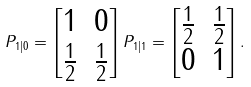<formula> <loc_0><loc_0><loc_500><loc_500>P _ { 1 | 0 } = \begin{bmatrix} 1 & 0 \\ \frac { 1 } { 2 } & \frac { 1 } { 2 } \\ \end{bmatrix} P _ { 1 | 1 } = \begin{bmatrix} \frac { 1 } { 2 } & \frac { 1 } { 2 } \\ 0 & 1 \\ \end{bmatrix} .</formula> 